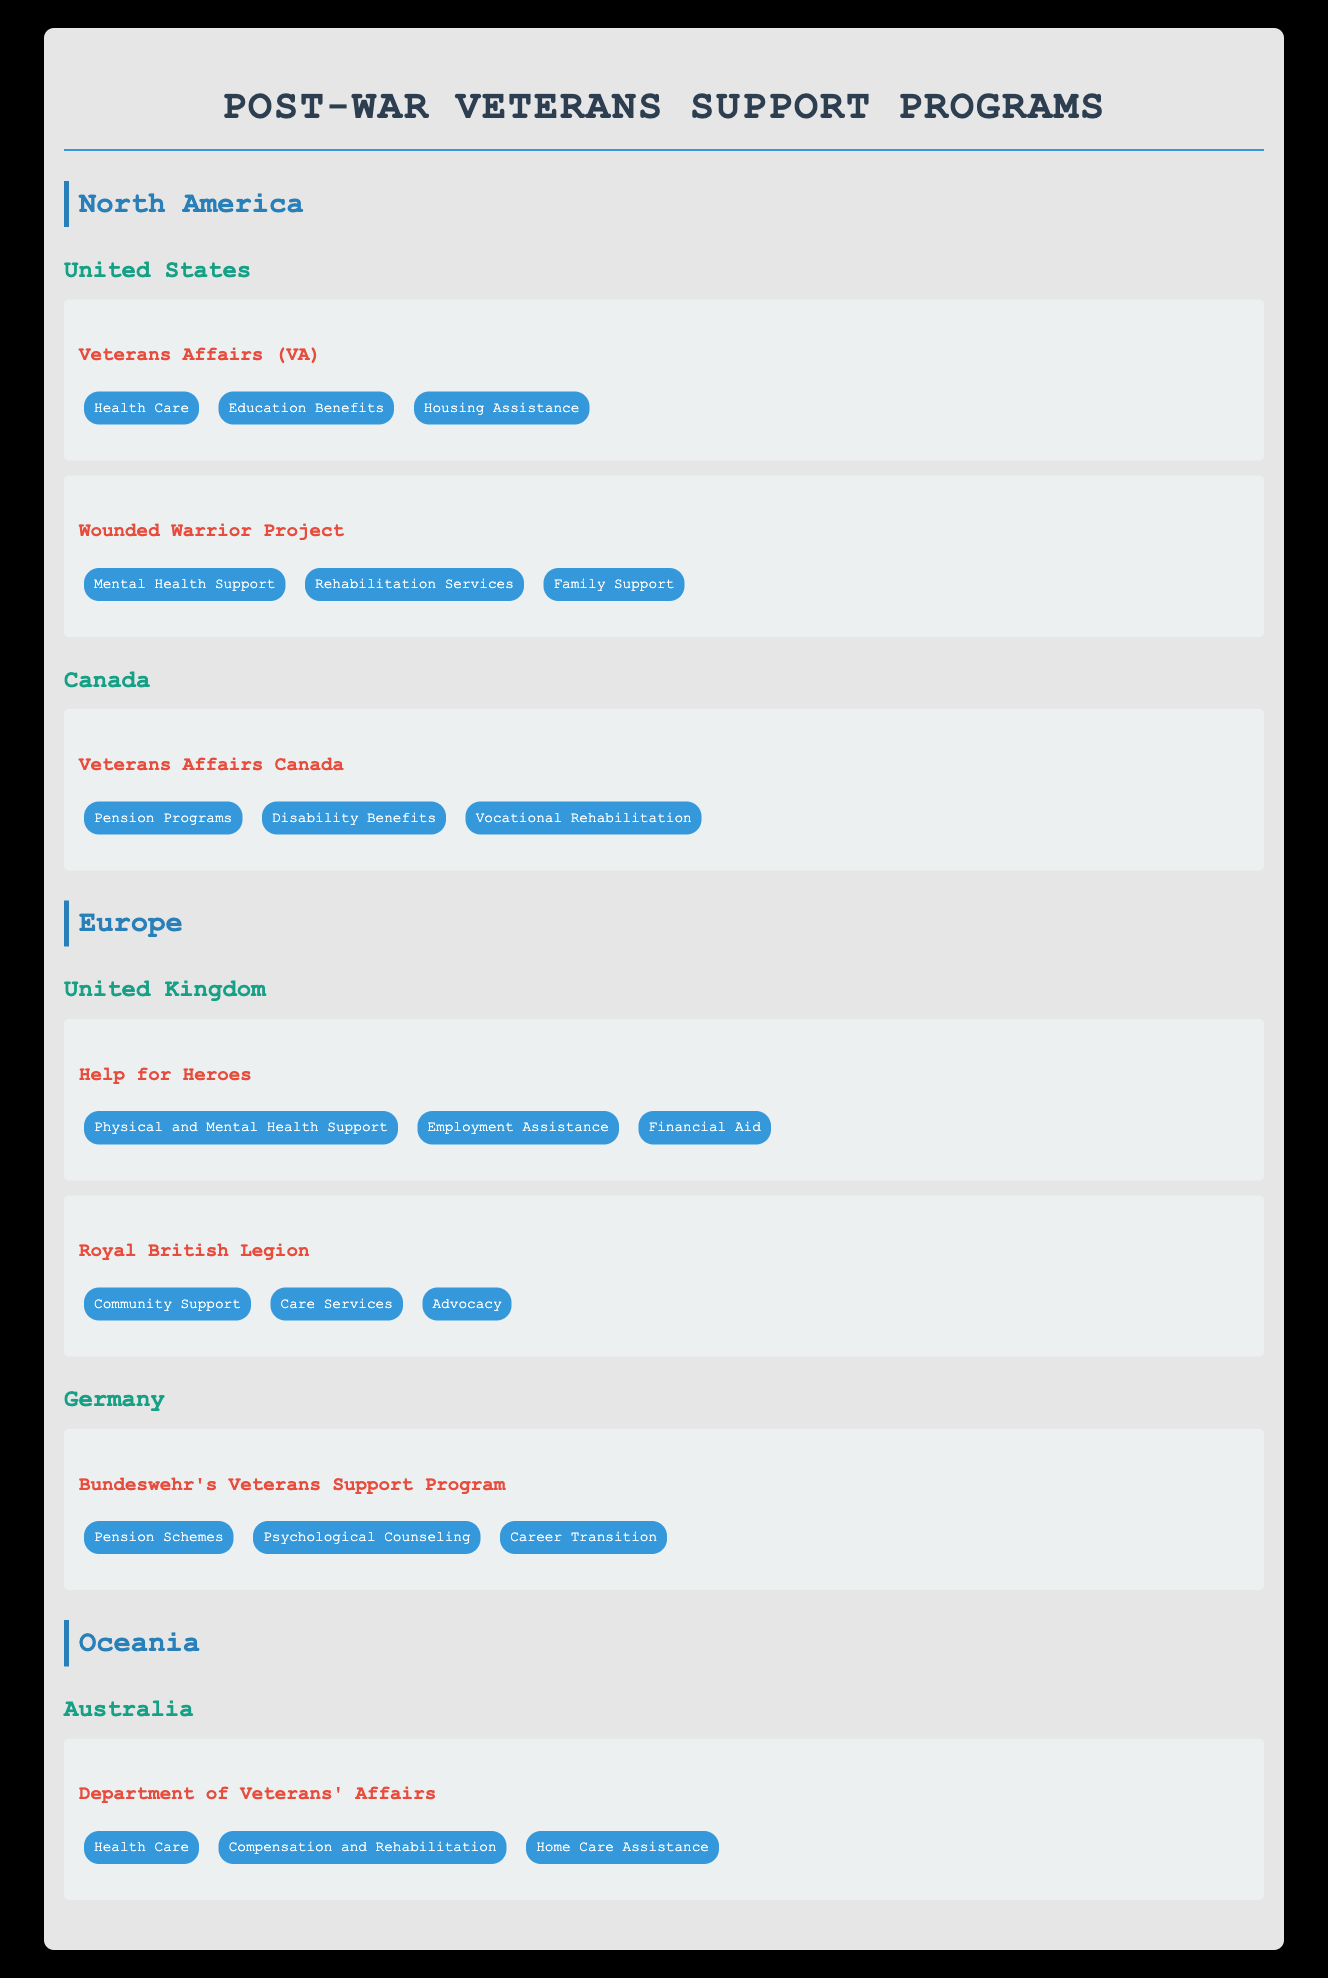What programs does the United States offer for veterans? The United States offers two programs for veterans: Veterans Affairs (VA) and Wounded Warrior Project. This information is directly listed under the "United States" section of the North America region in the table.
Answer: Veterans Affairs (VA), Wounded Warrior Project Does Canada have a veterans support program? Yes, Canada has a veterans support program called Veterans Affairs Canada. This is explicitly mentioned under the "Canada" section in the North America region of the table.
Answer: Yes How many different services does the Wounded Warrior Project provide? The Wounded Warrior Project provides three distinct services: Mental Health Support, Rehabilitation Services, and Family Support, as detailed under the program in the United States section.
Answer: 3 Which country in Europe has a veterans support program that includes psychological counseling? Germany has a veterans support program called Bundeswehr's Veterans Support Program, which includes psychological counseling among its services. This is explicitly stated under the Germany section of the Europe region in the table.
Answer: Germany What is the combined number of programs offered by North America and Europe? North America has three veteran support programs (Veterans Affairs (VA), Wounded Warrior Project, and Veterans Affairs Canada), while Europe has three programs (Help for Heroes, Royal British Legion, and Bundeswehr's Veterans Support Program). Adding these gives a total of 6 programs.
Answer: 6 Does Australia offer health care as part of its veterans support program? Yes, Australia has a program called Department of Veterans' Affairs, which explicitly lists Health Care as one of its services. This is stated under the Australia section in the Oceania region of the table.
Answer: Yes What services are offered by Help for Heroes in the United Kingdom? Help for Heroes offers three services: Physical and Mental Health Support, Employment Assistance, and Financial Aid. This information can be found under the program listed in the United Kingdom section of the Europe region in the table.
Answer: Physical and Mental Health Support, Employment Assistance, Financial Aid How many services does the Veterans Affairs Canada program provide compared to the Wounded Warrior Project? The Veterans Affairs Canada program provides three services: Pension Programs, Disability Benefits, and Vocational Rehabilitation. The Wounded Warrior Project provides three services: Mental Health Support, Rehabilitation Services, and Family Support. Therefore, both programs provide the same number of services, which is three.
Answer: They both provide 3 services 